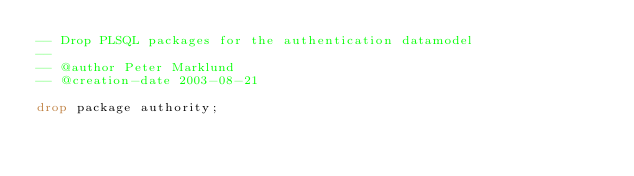Convert code to text. <code><loc_0><loc_0><loc_500><loc_500><_SQL_>-- Drop PLSQL packages for the authentication datamodel
--
-- @author Peter Marklund
-- @creation-date 2003-08-21

drop package authority;
</code> 